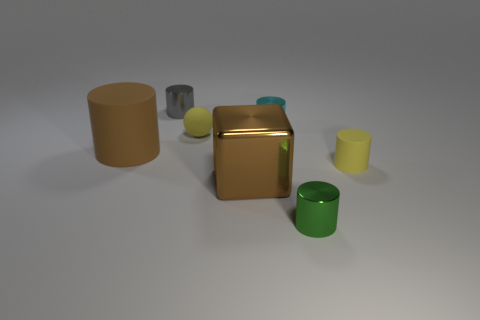Subtract 2 cylinders. How many cylinders are left? 3 Add 3 yellow matte cylinders. How many objects exist? 10 Subtract all cyan cylinders. How many cylinders are left? 4 Subtract all yellow cylinders. How many cylinders are left? 4 Subtract all spheres. How many objects are left? 6 Subtract all blue cylinders. Subtract all blue cubes. How many cylinders are left? 5 Add 5 balls. How many balls are left? 6 Add 1 tiny yellow cylinders. How many tiny yellow cylinders exist? 2 Subtract 0 green balls. How many objects are left? 7 Subtract all tiny cyan cylinders. Subtract all brown cylinders. How many objects are left? 5 